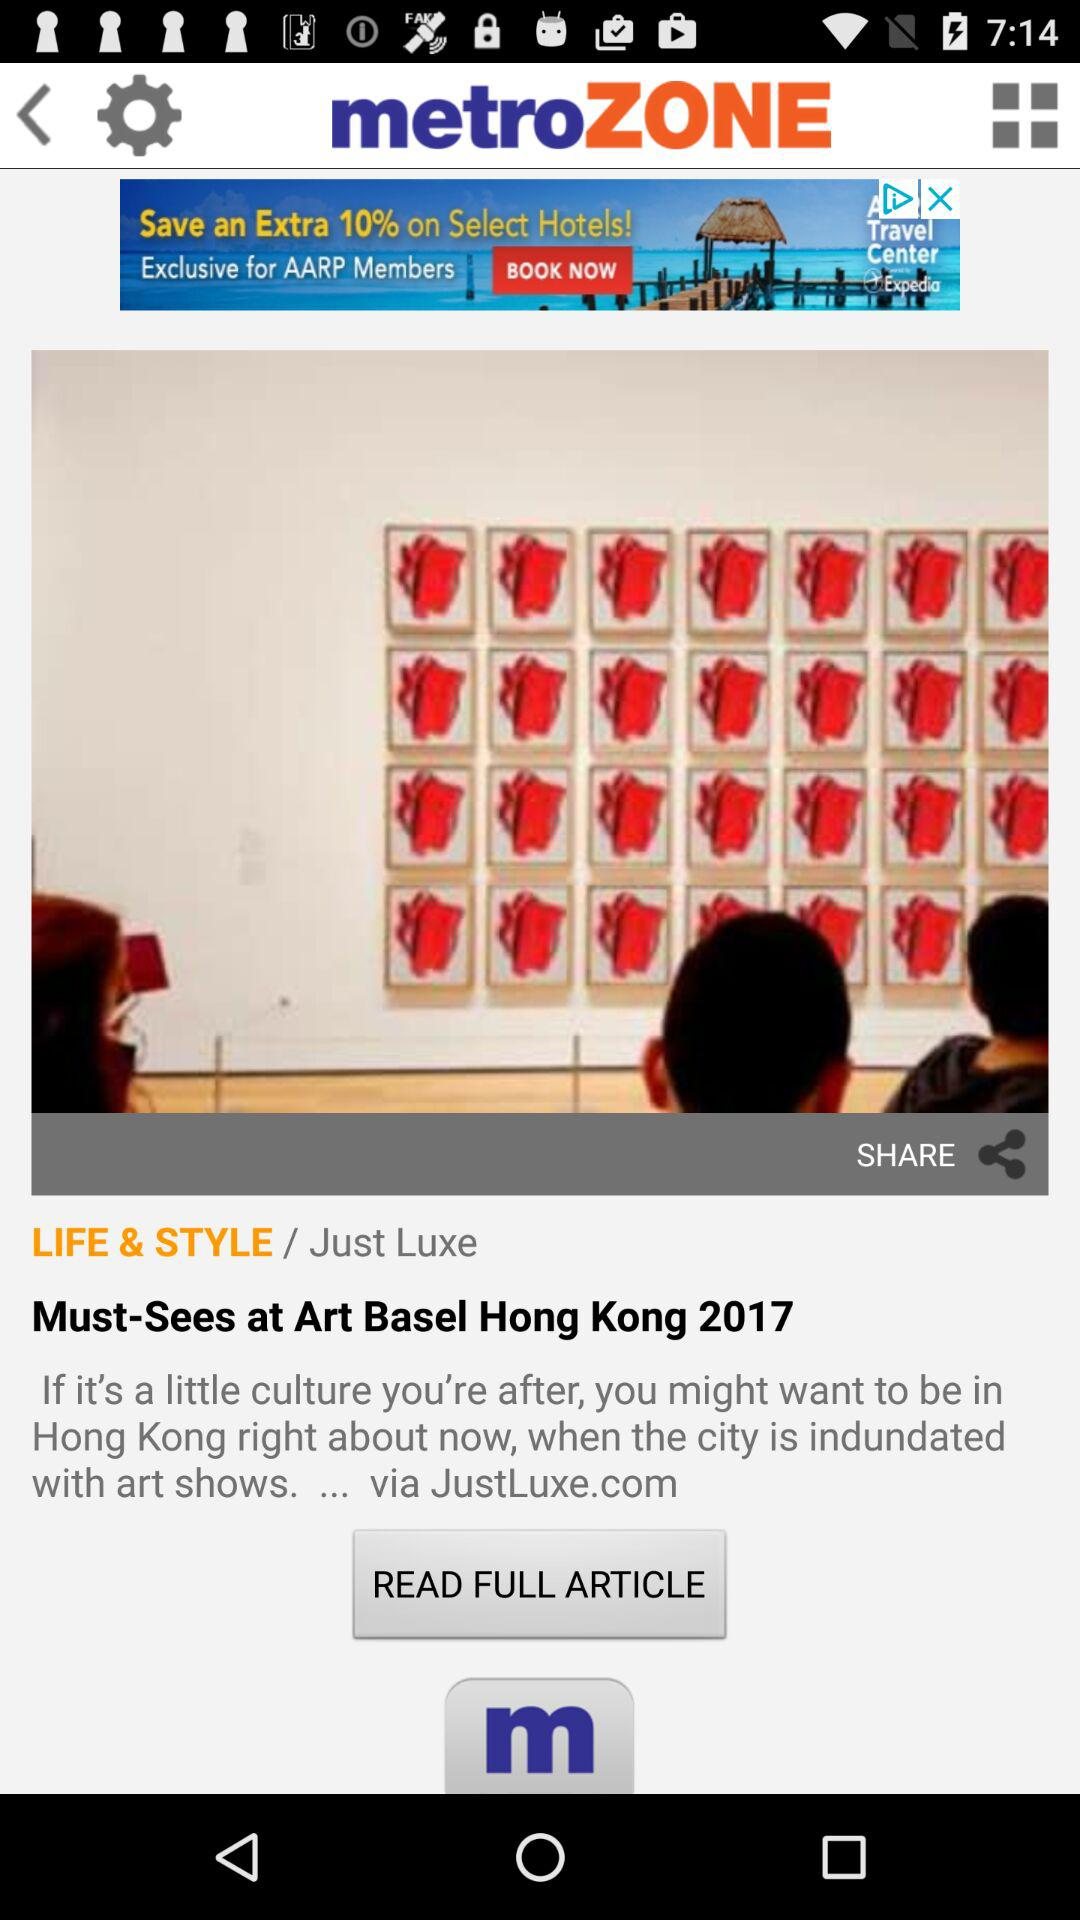What is the minimum age limit to use the service? The minimum age is 13 years. 